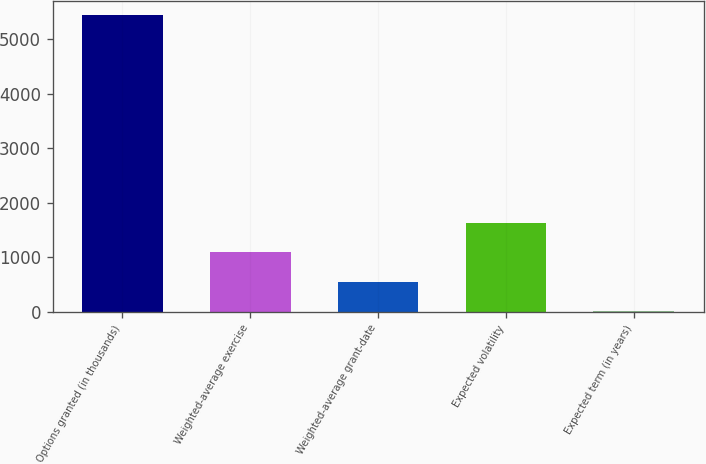<chart> <loc_0><loc_0><loc_500><loc_500><bar_chart><fcel>Options granted (in thousands)<fcel>Weighted-average exercise<fcel>Weighted-average grant-date<fcel>Expected volatility<fcel>Expected term (in years)<nl><fcel>5438<fcel>1091.6<fcel>548.3<fcel>1634.9<fcel>5<nl></chart> 